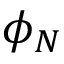<formula> <loc_0><loc_0><loc_500><loc_500>\phi _ { N }</formula> 